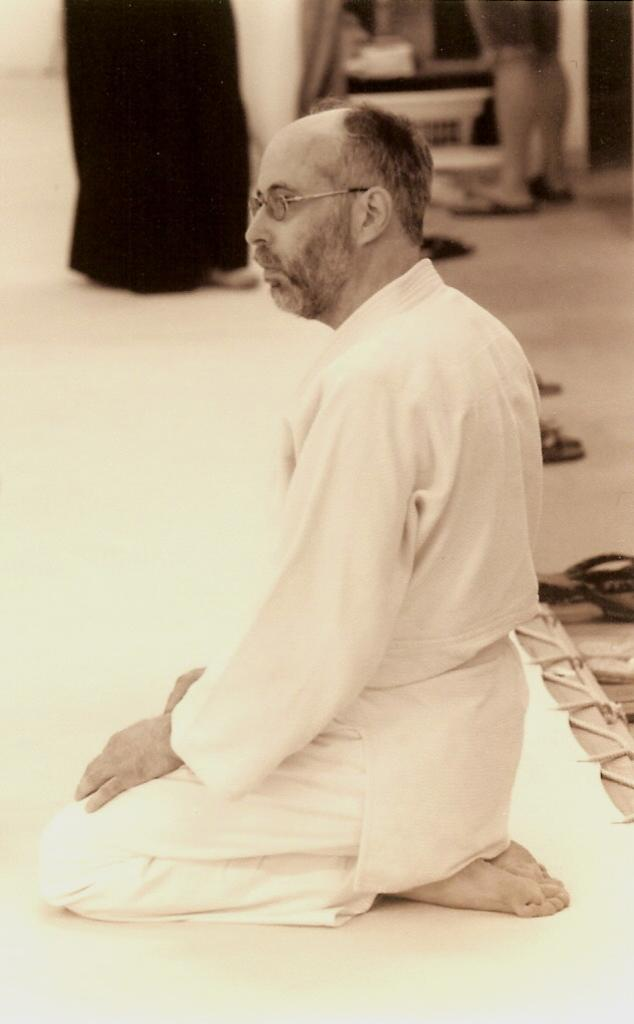What is the position of the person in the foreground of the image? The person is sitting on their knees in the image. Can you describe the background of the image? There are other persons and objects in the background of the image. What type of thrill can be seen on the person's feet in the image? There is no mention of feet or any thrill in the image; the person is sitting on their knees. 